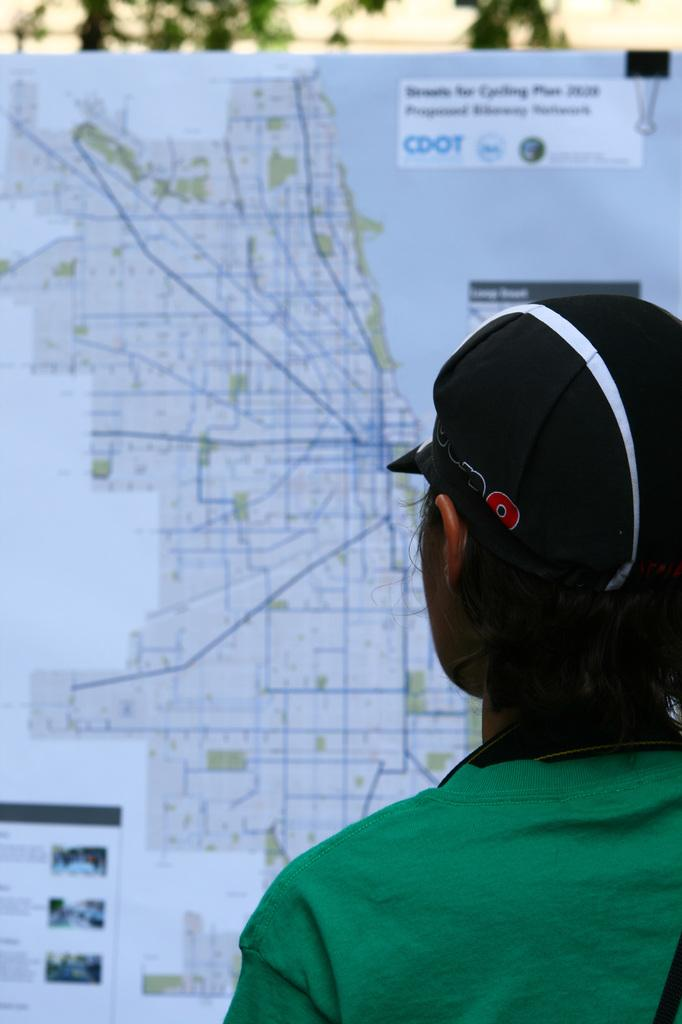Who or what is the main subject in the image? There is a person in the image. Can you describe the person's attire? The person is wearing a black cap. What can be seen in the background of the image? There is a board with a map and text in the background, and trees are also present. What type of trains can be seen in the image? There are no trains present in the image. What is the reason for the person wearing the black cap in the image? The image does not provide any information about the reason for the person wearing the black cap. 